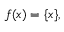<formula> <loc_0><loc_0><loc_500><loc_500>f ( x ) = \{ x \} ,</formula> 